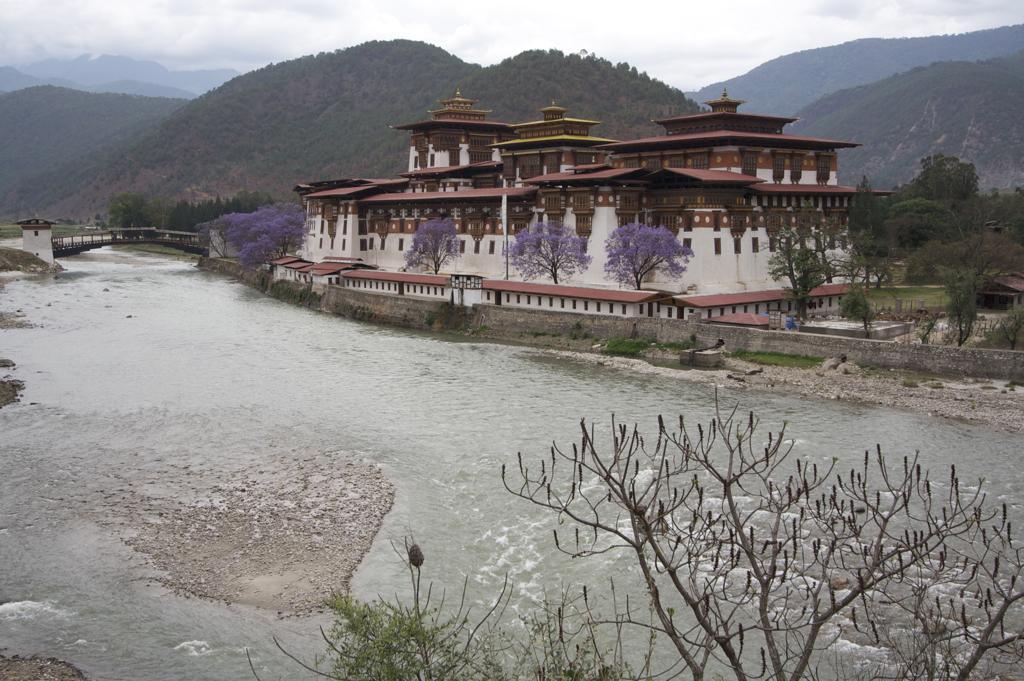Could you give a brief overview of what you see in this image? In this image there is a floating river with bridge on the top beside that there is a building, trees and mountains covered with trees. 